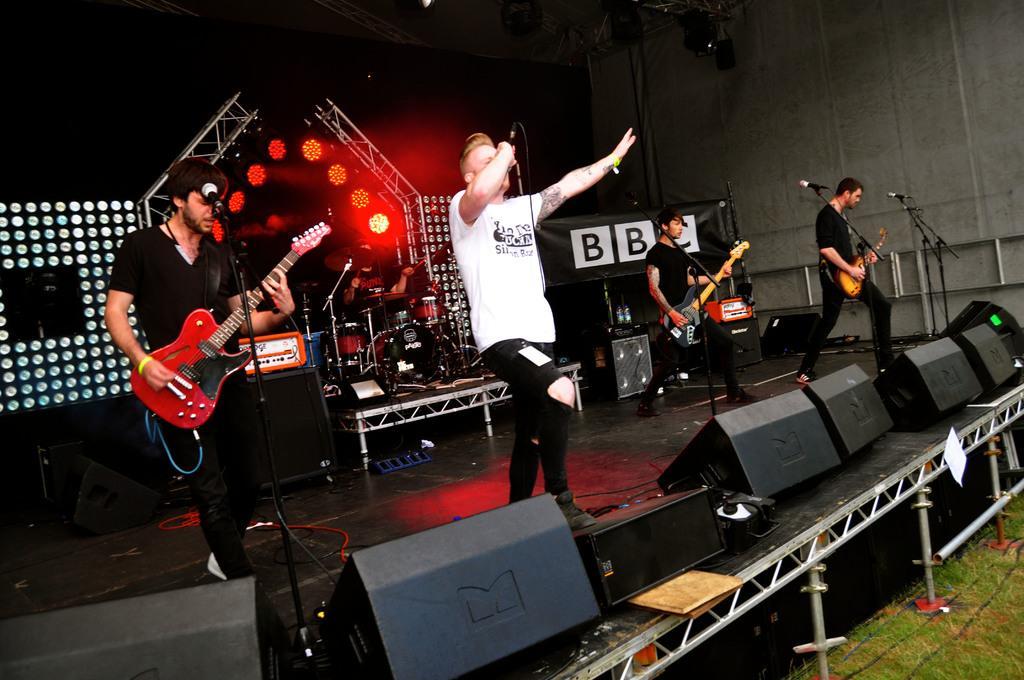How would you summarize this image in a sentence or two? In the image we can see there are people who are holding guitar in their and there is a man who is holding mic in his hand. 